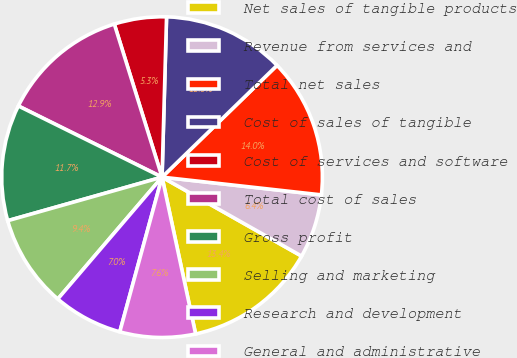Convert chart. <chart><loc_0><loc_0><loc_500><loc_500><pie_chart><fcel>Net sales of tangible products<fcel>Revenue from services and<fcel>Total net sales<fcel>Cost of sales of tangible<fcel>Cost of services and software<fcel>Total cost of sales<fcel>Gross profit<fcel>Selling and marketing<fcel>Research and development<fcel>General and administrative<nl><fcel>13.45%<fcel>6.43%<fcel>14.04%<fcel>12.28%<fcel>5.26%<fcel>12.87%<fcel>11.7%<fcel>9.36%<fcel>7.02%<fcel>7.6%<nl></chart> 